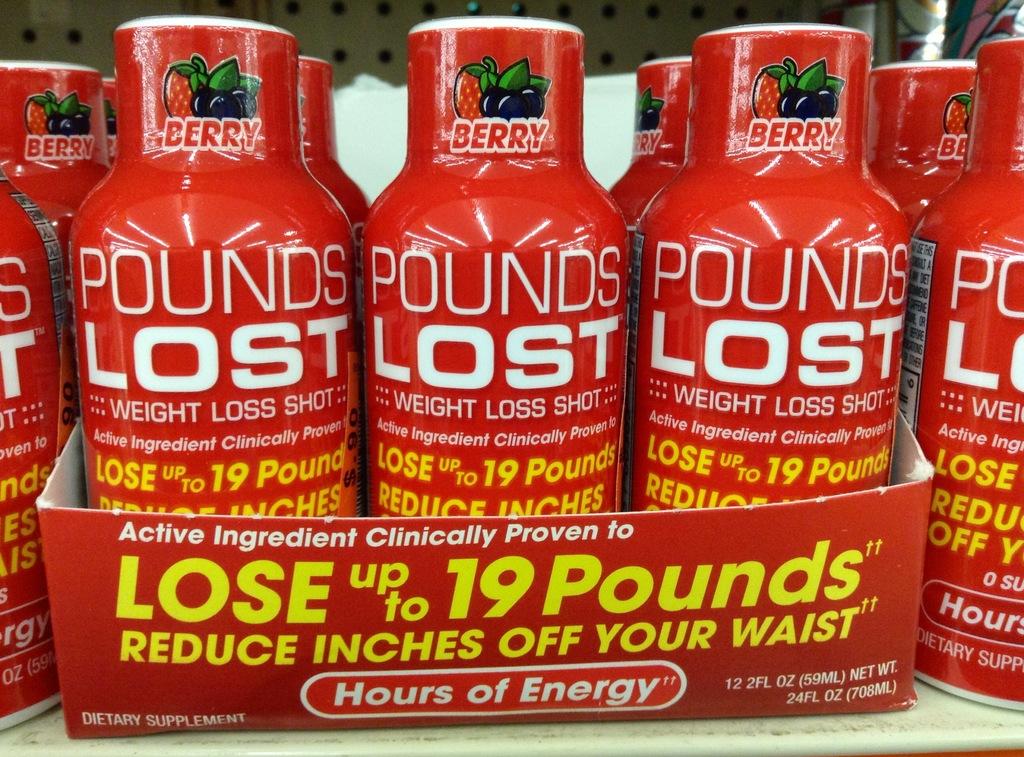What flavor is in the bottles?
Offer a very short reply. Berry. 